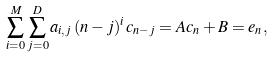<formula> <loc_0><loc_0><loc_500><loc_500>\sum _ { i = 0 } ^ { M } \sum _ { j = 0 } ^ { D } a _ { i , j } \, ( n - j ) ^ { i } \, c _ { n - j } = A c _ { n } + B = e _ { n } ,</formula> 